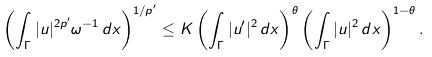Convert formula to latex. <formula><loc_0><loc_0><loc_500><loc_500>\left ( \int _ { \Gamma } | u | ^ { 2 p ^ { \prime } } \omega ^ { - 1 } \, d x \right ) ^ { 1 / p ^ { \prime } } \leq K \left ( \int _ { \Gamma } | u ^ { \prime } | ^ { 2 } \, d x \right ) ^ { \theta } \left ( \int _ { \Gamma } | u | ^ { 2 } \, d x \right ) ^ { 1 - \theta } .</formula> 